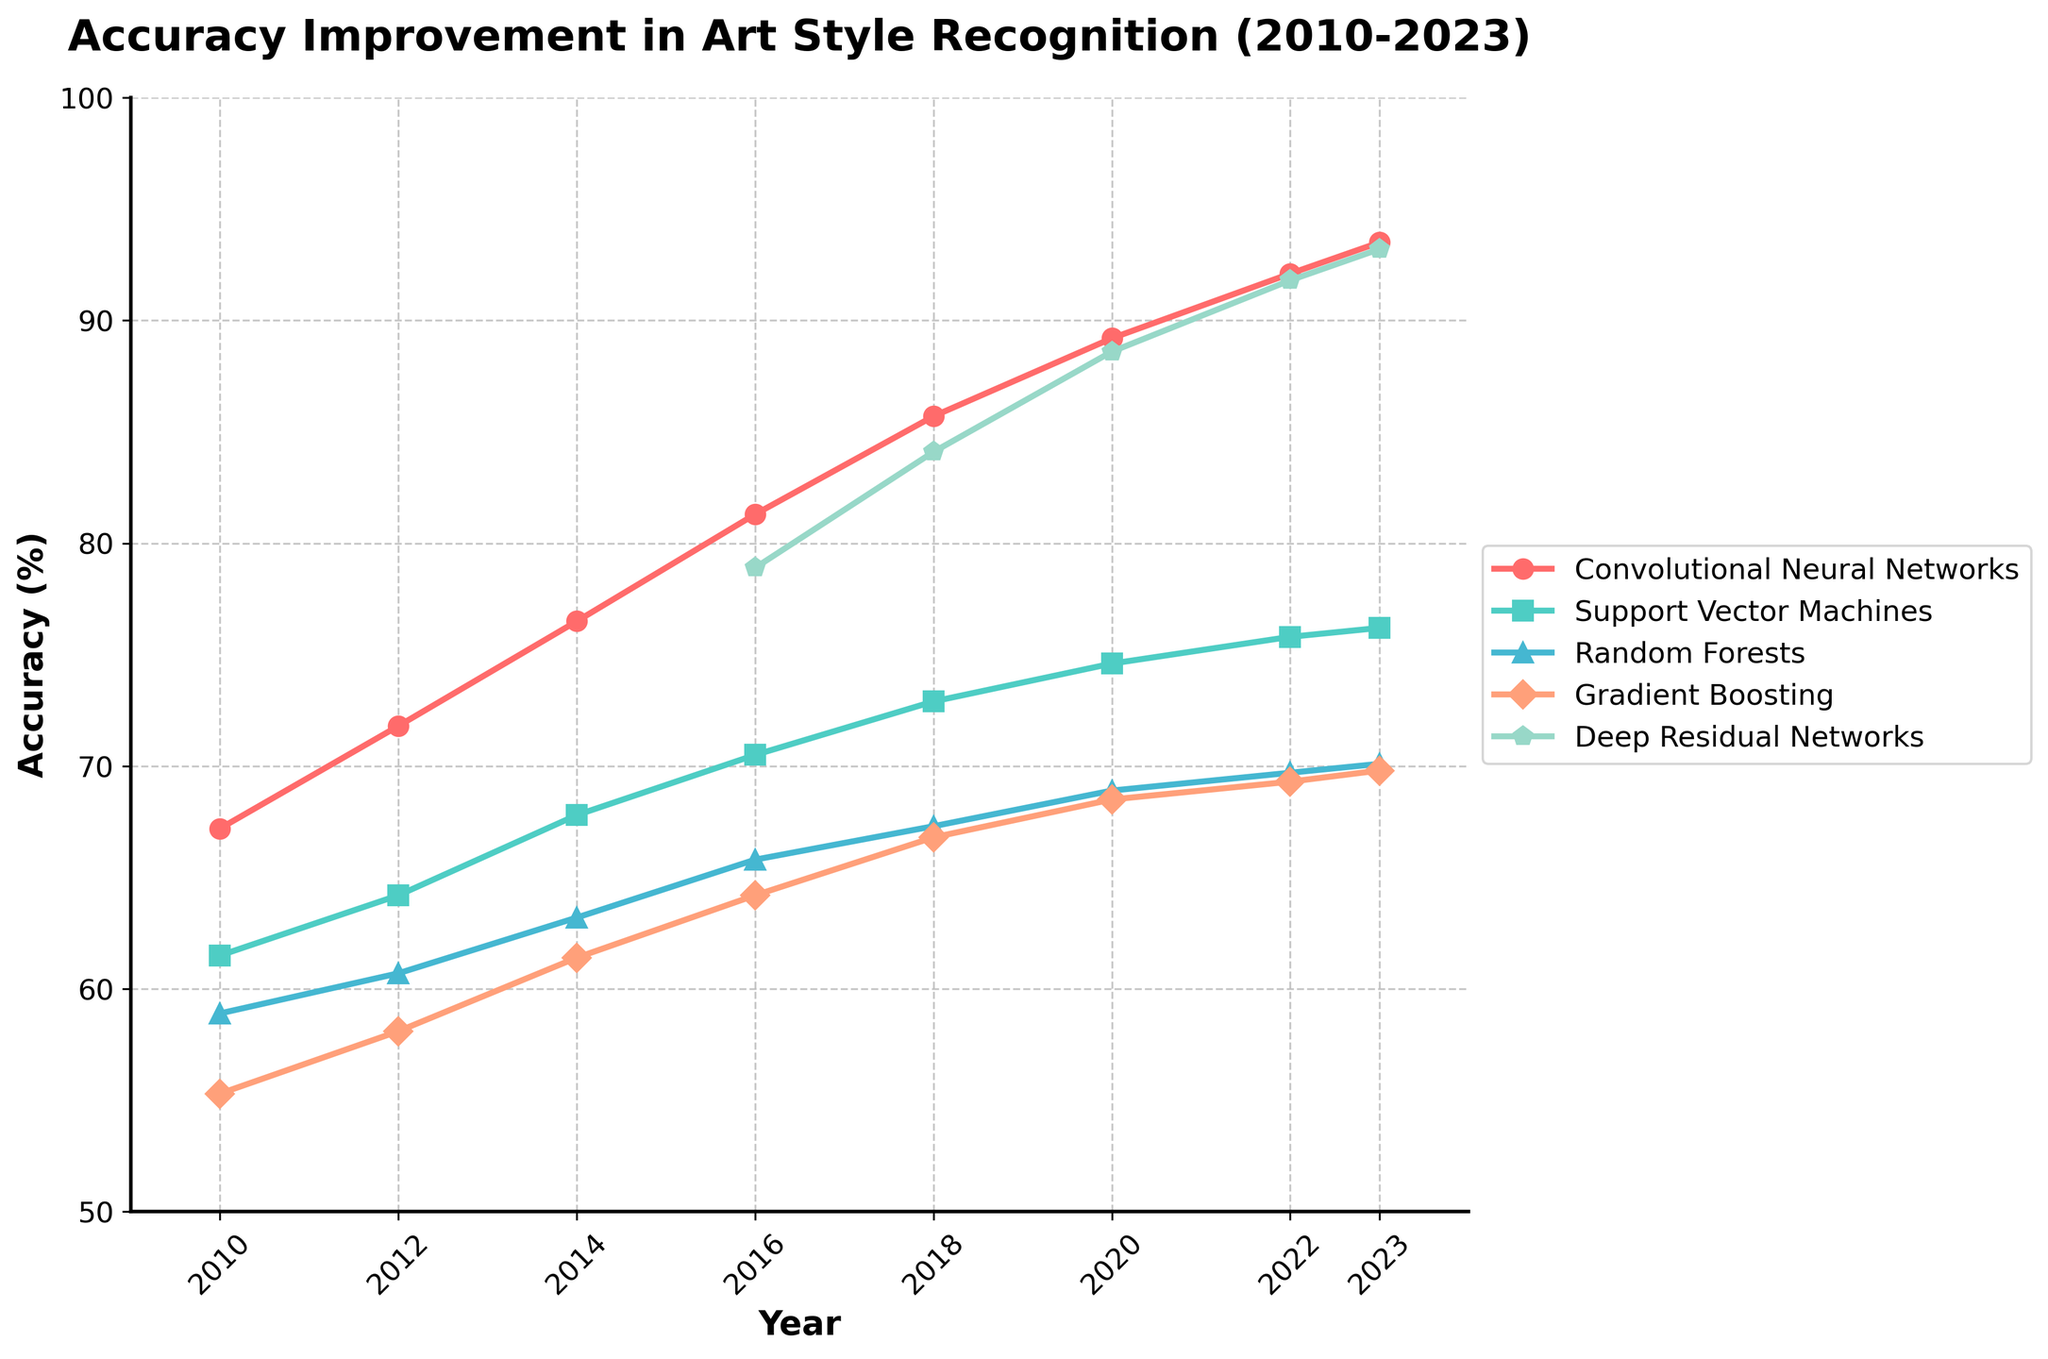Which algorithm had the highest accuracy in 2023? The line chart shows the year-wise accuracy of different algorithms. In 2023, Deep Residual Networks achieved the highest accuracy, as indicated at the top of the 2023 vertical line.
Answer: Deep Residual Networks How much did accuracy improve for Convolutional Neural Networks between 2012 and 2023? According to the chart, the accuracy for Convolutional Neural Networks was 71.8% in 2012 and increased to 93.5% in 2023. Subtracting the 2012 value from the 2023 value gives 93.5 - 71.8 = 21.7%.
Answer: 21.7% Which algorithm showed more improvement from 2016 to 2022, Random Forests or Gradient Boosting? For Random Forests, the accuracy improved from 65.8% in 2016 to 69.7% in 2022, a change of 69.7 - 65.8 = 3.9%. For Gradient Boosting, the accuracy improved from 64.2% in 2016 to 69.3% in 2022, a change of 69.3 - 64.2 = 5.1%. Gradient Boosting showed more improvement.
Answer: Gradient Boosting Between 2018 and 2023, which algorithm had a steady increase in accuracy without any decline? Observing the line plots from 2018 to 2023, Convolutional Neural Networks, Deep Residual Networks, and Support Vector Machines all show a consistent increase in accuracy without any declines. Random Forests and Gradient Boosting had steady trends but no decline.
Answer: Convolutional Neural Networks, Deep Residual Networks, Support Vector Machines, Random Forests, Gradient Boosting How did the introduction of Deep Residual Networks in 2016 affect the overall accuracy landscape? In 2016, Deep Residual Networks had a relatively high accuracy of 78.9%. By 2023, it reached an accuracy of 93.2%, indicating a significant improvement and positioning it among the leading algorithms in terms of recognition accuracy.
Answer: Significantly improved 